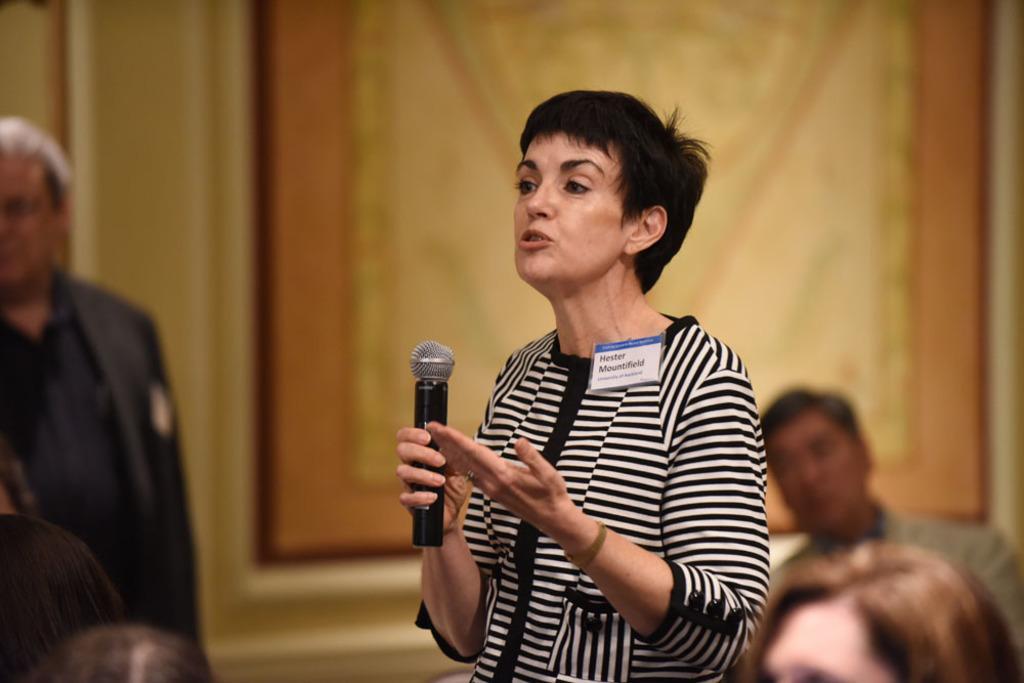Could you give a brief overview of what you see in this image? there is a woman talking in a microphone some people are listening to her 